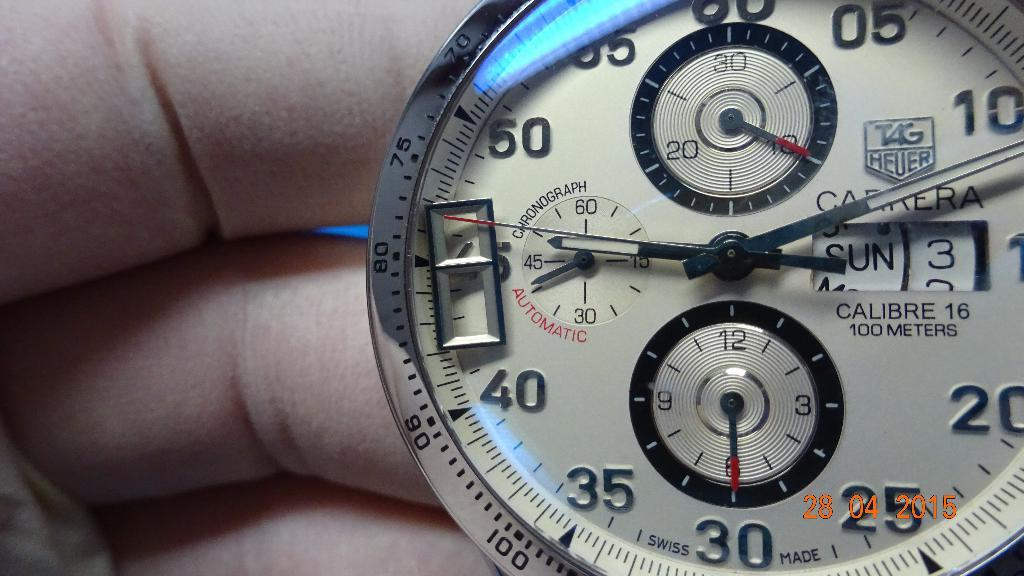<image>
Write a terse but informative summary of the picture. Person holding a watch which has the date on Sunday 3rd. 